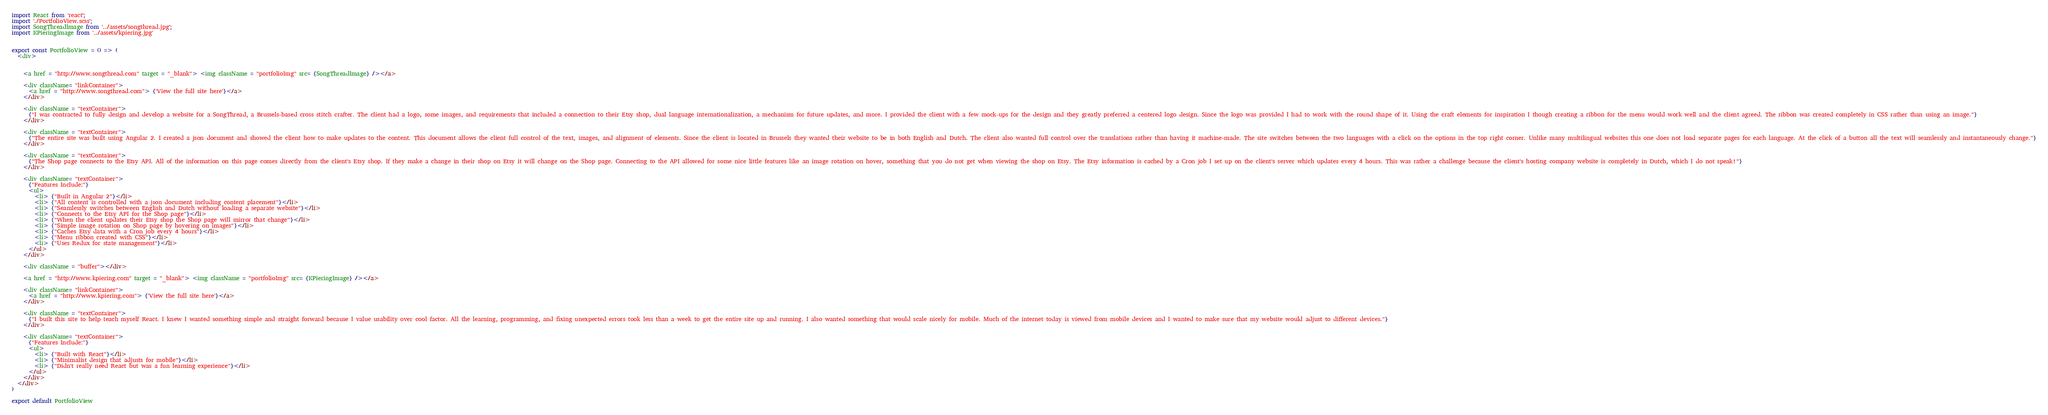Convert code to text. <code><loc_0><loc_0><loc_500><loc_500><_JavaScript_>import React from 'react';
import './PortfolioView.scss';
import SongThreadImage from '../assets/songthread.jpg';
import KPieringImage from '../assets/kpiering.jpg'


export const PortfolioView = () => (
  <div>
    

    <a href = "http://www.songthread.com" target = "_blank"> <img className = "portfolioImg" src= {SongThreadImage} /></a>

    <div className= "linkContainer">
      <a href = "http://www.songthread.com"> {'View the full site here'}</a>
    </div>

    <div className = "textContainer">
      {"I was contracted to fully design and develop a website for a SongThread, a Brussels-based cross stitch crafter. The client had a logo, some images, and requirements that included a connection to their Etsy shop, dual language internationalization, a mechanism for future updates, and more. I provided the client with a few mock-ups for the design and they greatly preferred a centered logo design. Since the logo was provided I had to work with the round shape of it. Using the craft elements for inspiration I though creating a ribbon for the menu would work well and the client agreed. The ribbon was created completely in CSS rather than using an image."}
    </div>

    <div className = "textContainer">
      {"The entire site was built using Angular 2. I created a json document and showed the client how to make updates to the content. This document allows the client full control of the text, images, and alignment of elements. Since the client is located in Brussels they wanted their website to be in both English and Dutch. The client also wanted full control over the translations rather than having it machine-made. The site switches between the two languages with a click on the options in the top right corner. Unlike many multilingual websites this one does not load separate pages for each language. At the click of a button all the text will seamlessly and instantaneously change."}
    </div>

    <div className = "textContainer">
      {"The Shop page connects to the Etsy API. All of the information on this page comes directly from the client's Etsy shop. If they make a change in their shop on Etsy it will change on the Shop page. Connecting to the API allowed for some nice little features like an image rotation on hover, something that you do not get when viewing the shop on Etsy. The Etsy information is cached by a Cron job I set up on the client's server which updates every 4 hours. This was rather a challenge because the client's hosting company website is completely in Dutch, which I do not speak!"}
    </div>

    <div className= "textContainer">
      {"Features Include:"}
      <ul>
        <li> {"Built in Angular 2"}</li>
        <li> {"All content is controlled with a json document including content placement"}</li>
        <li> {"Seamlessly switches between English and Dutch without loading a separate website"}</li>
        <li> {"Connects to the Etsy API for the Shop page"}</li>
        <li> {"When the client updates their Etsy shop the Shop page will mirror that change"}</li>
        <li> {"Simple image rotation on Shop page by hovering on images"}</li>
        <li> {"Caches Etsy data with a Cron job every 4 hours"}</li>
        <li> {"Menu ribbon created with CSS"}</li>
        <li> {"Uses Redux for state management"}</li>
      </ul>
    </div>

    <div className = "buffer"></div>

    <a href = "http://www.kpiering.com" target = "_blank"> <img className = "portfolioImg" src= {KPieringImage} /></a>

    <div className= "linkContainer">
      <a href = "http://www.kpiering.com"> {'View the full site here'}</a>
    </div>

    <div className = "textContainer">
      {"I built this site to help teach myself React. I knew I wanted something simple and straight forward because I value usability over cool factor. All the learning, programming, and fixing unexpected errors took less than a week to get the entire site up and running. I also wanted something that would scale nicely for mobile. Much of the internet today is viewed from mobile devices and I wanted to make sure that my website would adjust to different devices."}
    </div>

    <div className= "textContainer">
      {"Features Include:"}
      <ul>
        <li> {"Built with React"}</li>
        <li> {"Minimalist design that adjusts for mobile"}</li>
        <li> {"Didn't really need React but was a fun learning experience"}</li>
      </ul>
    </div>
  </div>
)

export default PortfolioView
</code> 